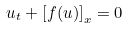<formula> <loc_0><loc_0><loc_500><loc_500>u _ { t } + \left [ f ( u ) \right ] _ { x } = 0</formula> 